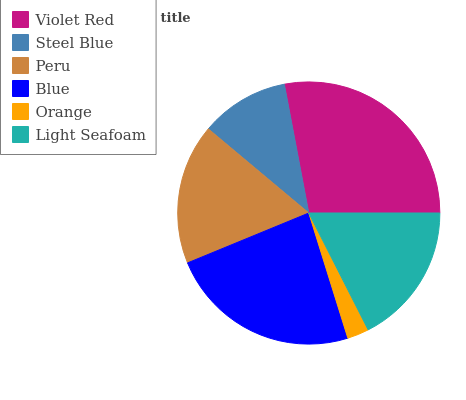Is Orange the minimum?
Answer yes or no. Yes. Is Violet Red the maximum?
Answer yes or no. Yes. Is Steel Blue the minimum?
Answer yes or no. No. Is Steel Blue the maximum?
Answer yes or no. No. Is Violet Red greater than Steel Blue?
Answer yes or no. Yes. Is Steel Blue less than Violet Red?
Answer yes or no. Yes. Is Steel Blue greater than Violet Red?
Answer yes or no. No. Is Violet Red less than Steel Blue?
Answer yes or no. No. Is Light Seafoam the high median?
Answer yes or no. Yes. Is Peru the low median?
Answer yes or no. Yes. Is Steel Blue the high median?
Answer yes or no. No. Is Orange the low median?
Answer yes or no. No. 